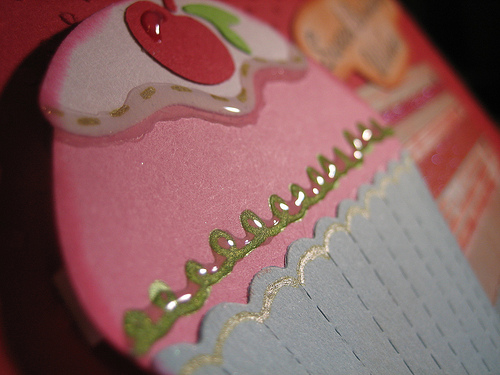<image>
Is the cherry above the paper? No. The cherry is not positioned above the paper. The vertical arrangement shows a different relationship. 